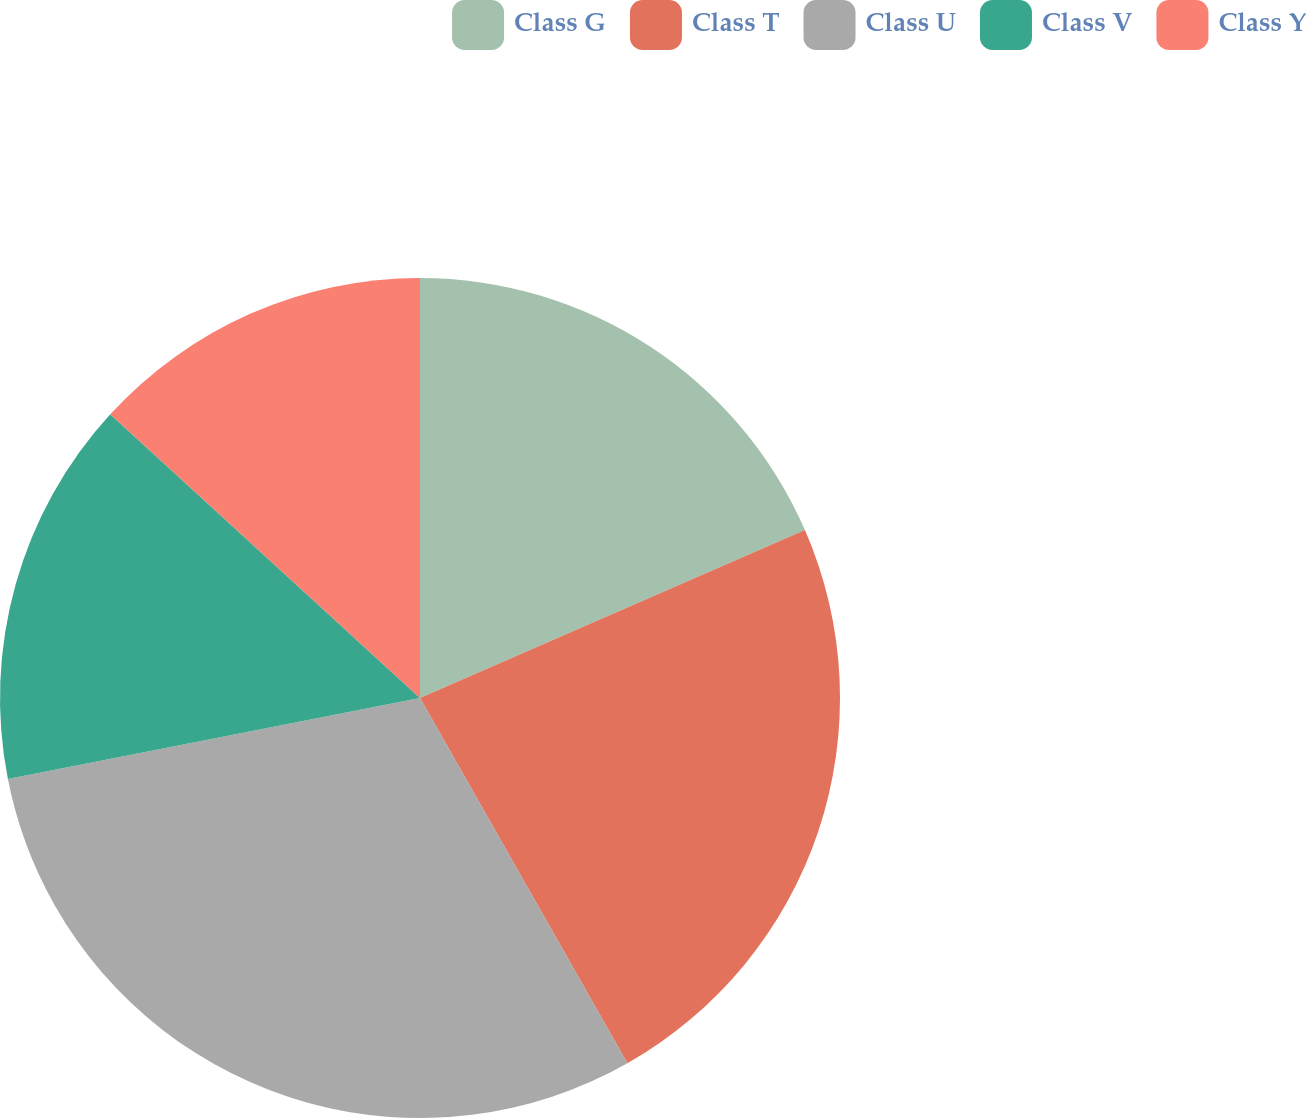<chart> <loc_0><loc_0><loc_500><loc_500><pie_chart><fcel>Class G<fcel>Class T<fcel>Class U<fcel>Class V<fcel>Class Y<nl><fcel>18.45%<fcel>23.33%<fcel>30.13%<fcel>14.89%<fcel>13.2%<nl></chart> 